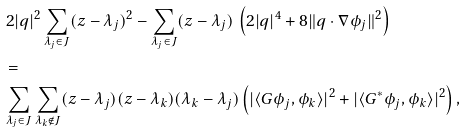<formula> <loc_0><loc_0><loc_500><loc_500>& \, 2 | { q } | ^ { 2 } \sum _ { \lambda _ { j } \in J } ( z - \lambda _ { j } ) ^ { 2 } - \sum _ { \lambda _ { j } \in J } ( z - \lambda _ { j } ) \, \left ( 2 | { q } | ^ { 4 } + 8 \| { q } \cdot \nabla \phi _ { j } \| ^ { 2 } \right ) \\ & = \\ & \sum _ { \lambda _ { j } \in J } \sum _ { \lambda _ { k } \notin J } ( z - \lambda _ { j } ) ( z - \lambda _ { k } ) ( \lambda _ { k } - \lambda _ { j } ) \left ( | \langle G \phi _ { j } , \phi _ { k } \rangle | ^ { 2 } + | \langle G ^ { * } \phi _ { j } , \phi _ { k } \rangle | ^ { 2 } \right ) , \\</formula> 